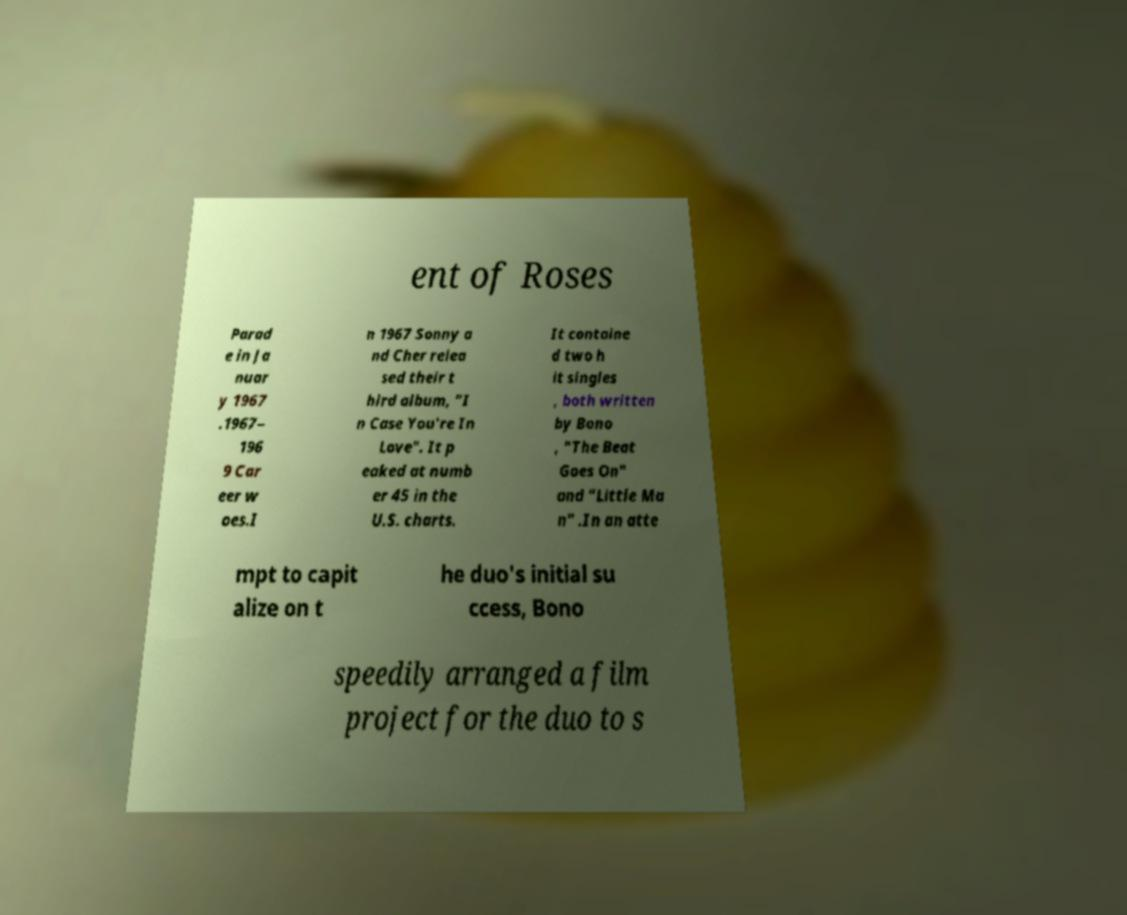Could you extract and type out the text from this image? ent of Roses Parad e in Ja nuar y 1967 .1967– 196 9 Car eer w oes.I n 1967 Sonny a nd Cher relea sed their t hird album, "I n Case You're In Love". It p eaked at numb er 45 in the U.S. charts. It containe d two h it singles , both written by Bono , "The Beat Goes On" and "Little Ma n" .In an atte mpt to capit alize on t he duo's initial su ccess, Bono speedily arranged a film project for the duo to s 